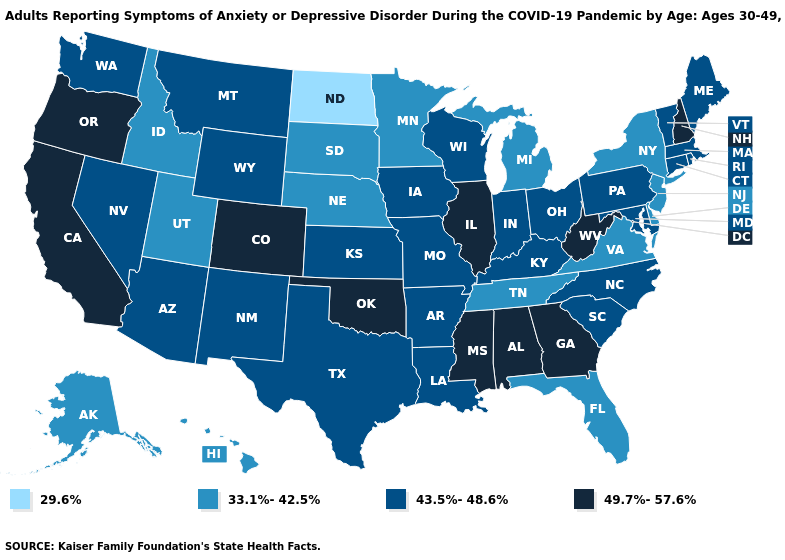What is the value of Arkansas?
Be succinct. 43.5%-48.6%. Does Indiana have the same value as Arizona?
Be succinct. Yes. Among the states that border New York , does New Jersey have the highest value?
Quick response, please. No. Which states hav the highest value in the MidWest?
Answer briefly. Illinois. Does Maine have the highest value in the Northeast?
Write a very short answer. No. What is the highest value in the USA?
Write a very short answer. 49.7%-57.6%. Name the states that have a value in the range 49.7%-57.6%?
Keep it brief. Alabama, California, Colorado, Georgia, Illinois, Mississippi, New Hampshire, Oklahoma, Oregon, West Virginia. What is the value of New Jersey?
Be succinct. 33.1%-42.5%. What is the highest value in states that border South Dakota?
Concise answer only. 43.5%-48.6%. What is the value of Nebraska?
Give a very brief answer. 33.1%-42.5%. What is the value of Washington?
Be succinct. 43.5%-48.6%. Among the states that border Ohio , does Michigan have the lowest value?
Concise answer only. Yes. Name the states that have a value in the range 43.5%-48.6%?
Concise answer only. Arizona, Arkansas, Connecticut, Indiana, Iowa, Kansas, Kentucky, Louisiana, Maine, Maryland, Massachusetts, Missouri, Montana, Nevada, New Mexico, North Carolina, Ohio, Pennsylvania, Rhode Island, South Carolina, Texas, Vermont, Washington, Wisconsin, Wyoming. Does Nebraska have the highest value in the USA?
Quick response, please. No. 